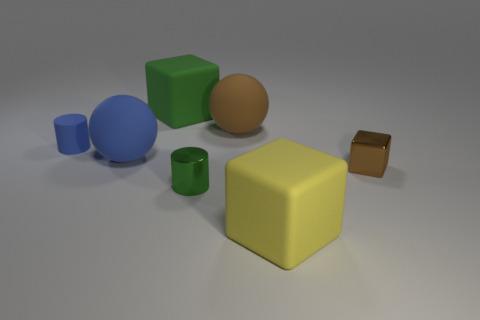What is the shape of the brown metal thing that is the same size as the green cylinder?
Your answer should be very brief. Cube. Are there any small red shiny objects that have the same shape as the green shiny thing?
Provide a succinct answer. No. There is a matte object in front of the metal block; is it the same size as the brown metallic block?
Your response must be concise. No. What is the size of the object that is both to the left of the big brown rubber ball and to the right of the green matte block?
Make the answer very short. Small. How many other objects are the same material as the large blue thing?
Make the answer very short. 4. There is a rubber cube in front of the tiny blue object; what is its size?
Your response must be concise. Large. What number of tiny objects are metallic blocks or yellow things?
Provide a succinct answer. 1. Is there anything else that has the same color as the small metallic block?
Your answer should be compact. Yes. There is a small blue thing; are there any tiny brown objects right of it?
Your answer should be very brief. Yes. There is a thing that is right of the yellow object that is in front of the large blue sphere; what is its size?
Your answer should be very brief. Small. 